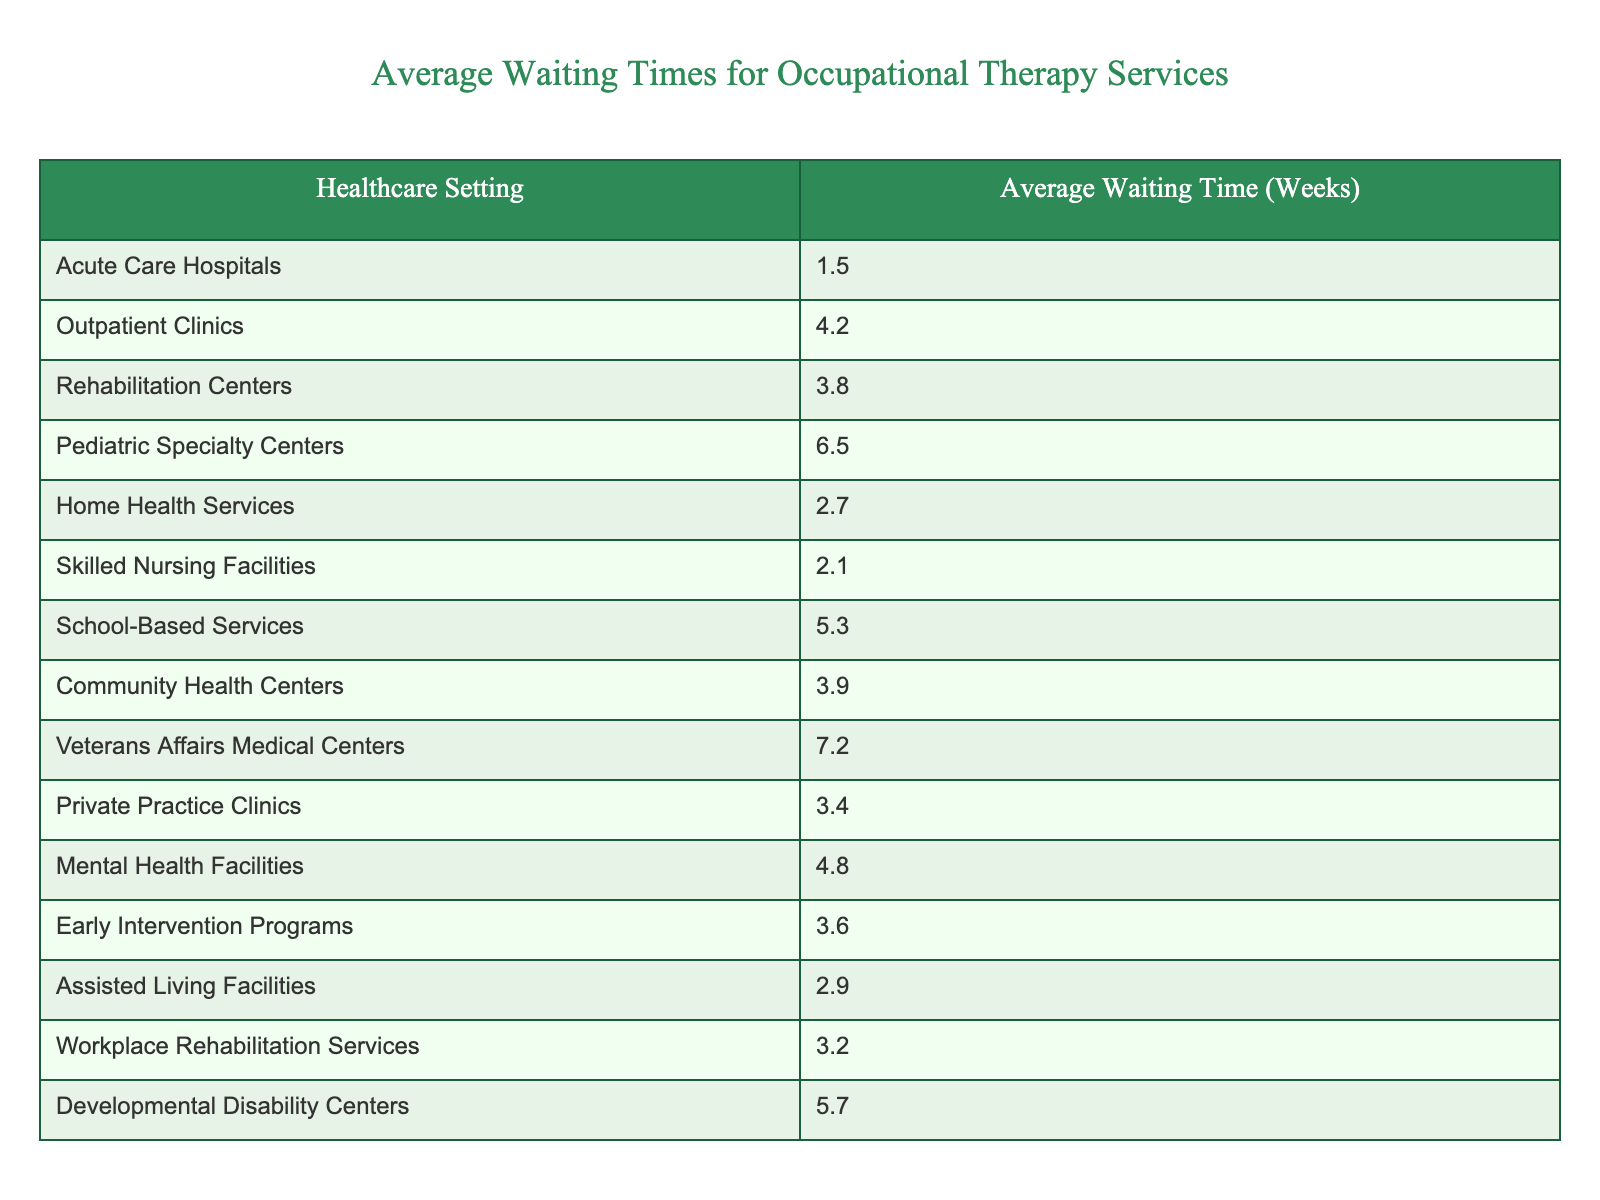What is the average waiting time for occupational therapy services in Acute Care Hospitals? The table shows that the average waiting time for Acute Care Hospitals is listed directly as 1.5 weeks.
Answer: 1.5 weeks Which healthcare setting has the longest average waiting time for occupational therapy services? By examining the average waiting times in the table, Veterans Affairs Medical Centers have the longest waiting time at 7.2 weeks.
Answer: Veterans Affairs Medical Centers What is the average waiting time for services in Community Health Centers and Rehabilitation Centers combined? To find the combined average, first add the average waiting times: 3.9 (Community Health Centers) + 3.8 (Rehabilitation Centers) = 7.7 weeks. Then, divide by 2 for the average: 7.7/2 = 3.85 weeks.
Answer: 3.85 weeks Is the average waiting time longer for Pediatric Specialty Centers than for School-Based Services? The table shows that Pediatric Specialty Centers have an average waiting time of 6.5 weeks, while School-Based Services have 5.3 weeks. Since 6.5 is greater than 5.3, the answer is yes.
Answer: Yes What is the difference in average waiting time between Home Health Services and Skilled Nursing Facilities? The average waiting time for Home Health Services is 2.7 weeks, and for Skilled Nursing Facilities, it is 2.1 weeks. The difference is 2.7 - 2.1 = 0.6 weeks.
Answer: 0.6 weeks If you combine the average waiting times for Outpatient Clinics and Private Practice Clinics, what would be the average waiting time for those two settings? First, add the average waiting times: 4.2 (Outpatient Clinics) + 3.4 (Private Practice Clinics) = 7.6 weeks. Then, divide this sum by 2 to get the average: 7.6/2 = 3.8 weeks.
Answer: 3.8 weeks Which two healthcare settings have an average waiting time that is less than 3 weeks? Examining the table, both Acute Care Hospitals (1.5 weeks) and Skilled Nursing Facilities (2.1 weeks) have waiting times less than 3 weeks.
Answer: Acute Care Hospitals and Skilled Nursing Facilities What percentage increase in average waiting time do Rehabilitation Centers display compared to Home Health Services? Rehabilitation Centers have an average waiting time of 3.8 weeks, and Home Health Services have 2.7 weeks. The increase is 3.8 - 2.7 = 1.1 weeks. The percentage increase is (1.1/2.7) * 100 = approximately 40.74%.
Answer: Approximately 40.74% Which settings have a waiting time above the average of 4 weeks? From the table, the settings that have waiting times above 4 weeks are Pediatric Specialty Centers (6.5 weeks) and Veterans Affairs Medical Centers (7.2 weeks).
Answer: Pediatric Specialty Centers and Veterans Affairs Medical Centers If the average waiting time for Early Intervention Programs is added to that of Mental Health Facilities, what is the total? Early Intervention Programs have an average of 3.6 weeks and Mental Health Facilities have 4.8 weeks. Adding them gives 3.6 + 4.8 = 8.4 weeks.
Answer: 8.4 weeks 